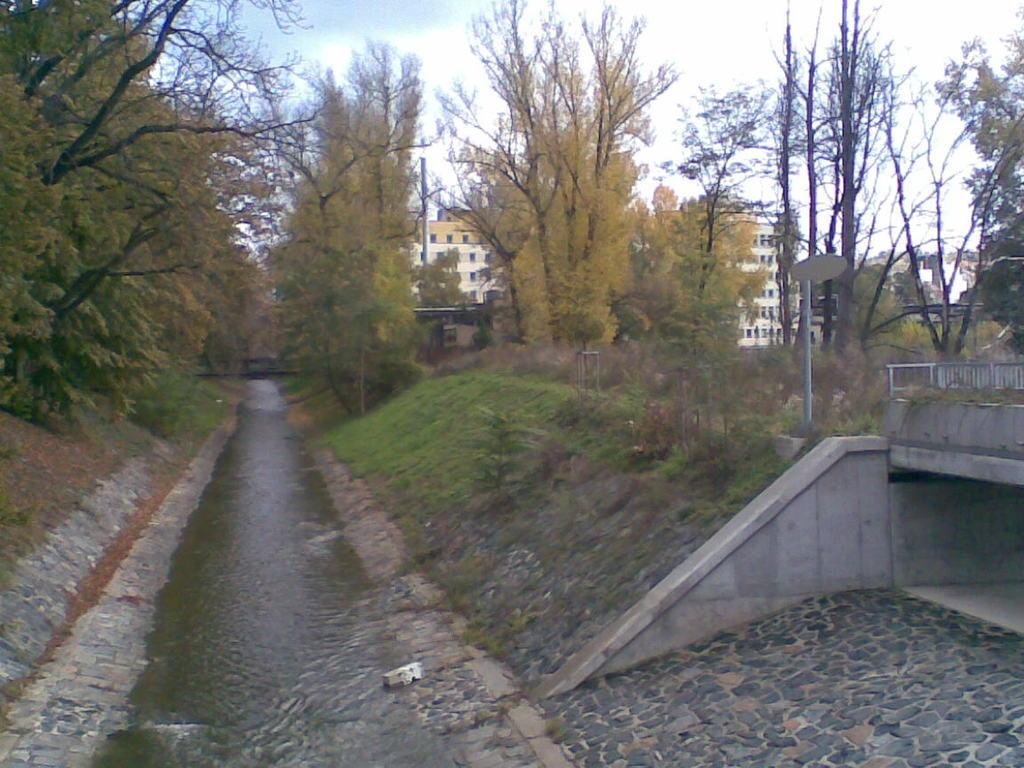What type of natural environment is depicted in the image? The image contains water, grass, plants, and trees, which are all elements of a natural environment. What type of structures can be seen in the image? There are buildings in the image. What is visible in the background of the image? The sky is visible in the background of the image. What type of houses can be seen in the image? There is no mention of houses in the image; only buildings are mentioned. What type of brush is being used to paint the image? The provided facts do not mention any painting or brushes; they only describe the elements present in the image. 